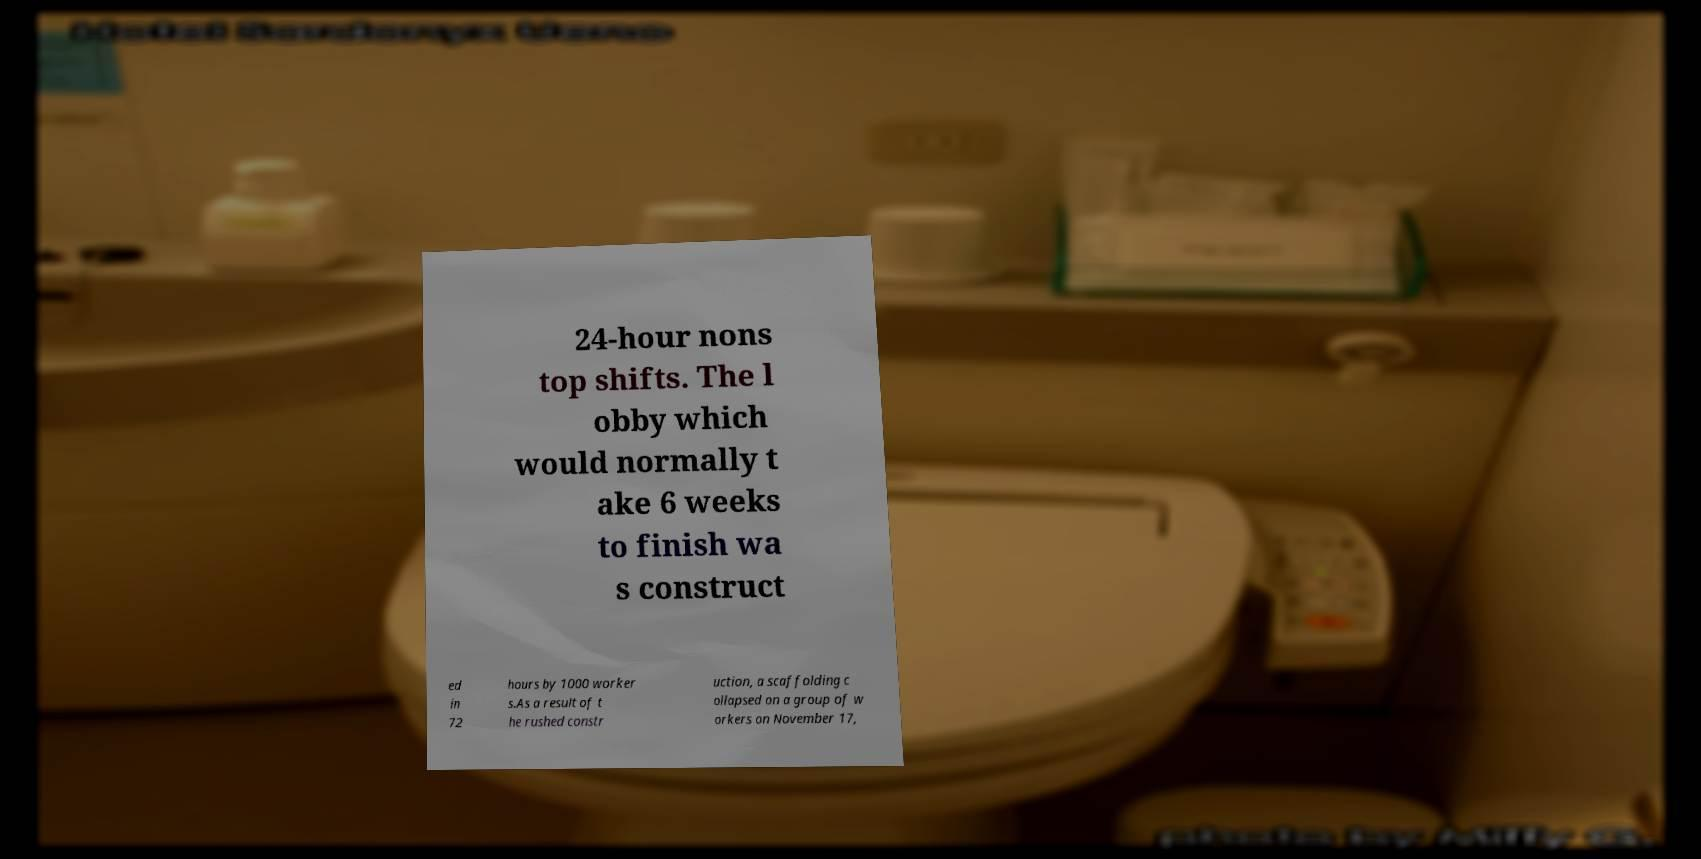Could you assist in decoding the text presented in this image and type it out clearly? 24-hour nons top shifts. The l obby which would normally t ake 6 weeks to finish wa s construct ed in 72 hours by 1000 worker s.As a result of t he rushed constr uction, a scaffolding c ollapsed on a group of w orkers on November 17, 